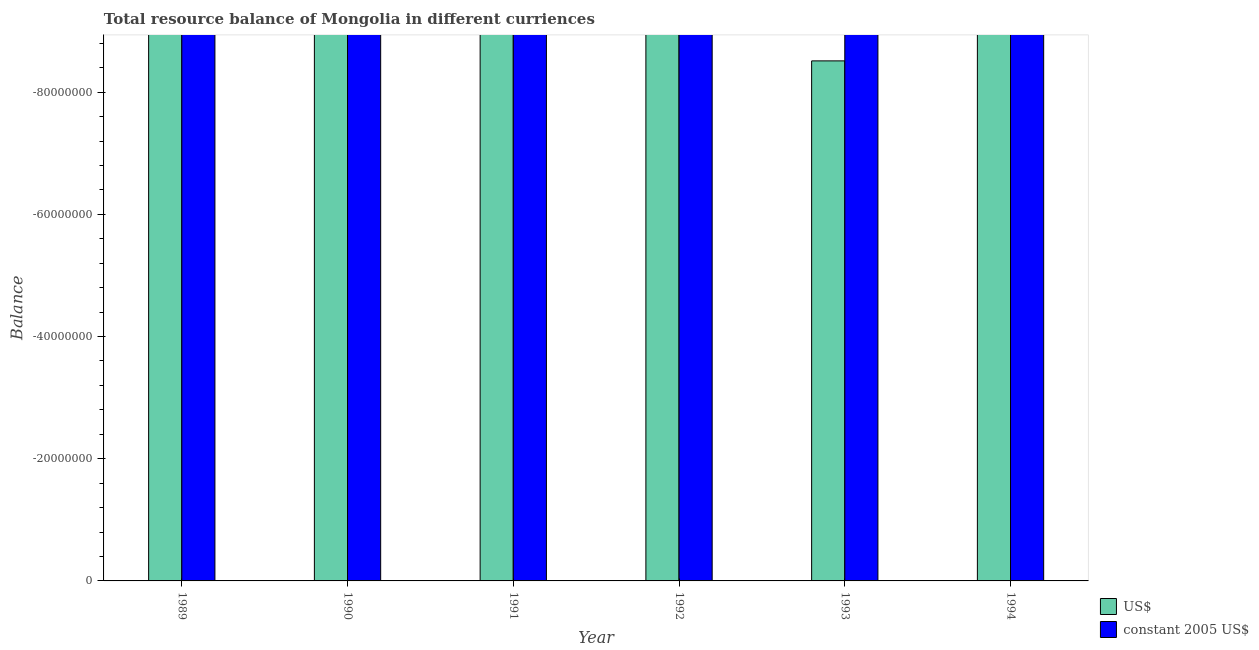Are the number of bars on each tick of the X-axis equal?
Give a very brief answer. Yes. What is the average resource balance in us$ per year?
Make the answer very short. 0. In how many years, is the resource balance in constant us$ greater than -60000000 units?
Your answer should be compact. 0. How many legend labels are there?
Your answer should be compact. 2. How are the legend labels stacked?
Your answer should be very brief. Vertical. What is the title of the graph?
Give a very brief answer. Total resource balance of Mongolia in different curriences. Does "Food and tobacco" appear as one of the legend labels in the graph?
Give a very brief answer. No. What is the label or title of the Y-axis?
Offer a terse response. Balance. What is the Balance in US$ in 1989?
Provide a short and direct response. 0. What is the Balance in constant 2005 US$ in 1990?
Provide a short and direct response. 0. What is the Balance in US$ in 1993?
Keep it short and to the point. 0. What is the Balance of constant 2005 US$ in 1993?
Offer a terse response. 0. What is the Balance in US$ in 1994?
Provide a short and direct response. 0. What is the Balance in constant 2005 US$ in 1994?
Your answer should be very brief. 0. What is the average Balance in constant 2005 US$ per year?
Provide a succinct answer. 0. 